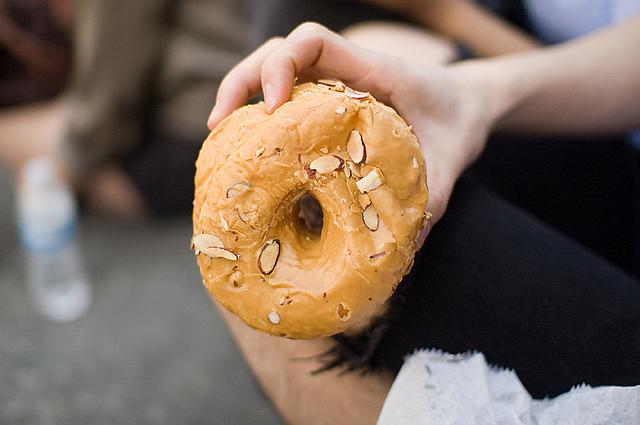Where is a water bottle?
Be succinct. Ground. Does the food have a bite taken out of it?
Quick response, please. No. What is the topping?
Concise answer only. Almonds. Is this a doughnut?
Be succinct. Yes. 